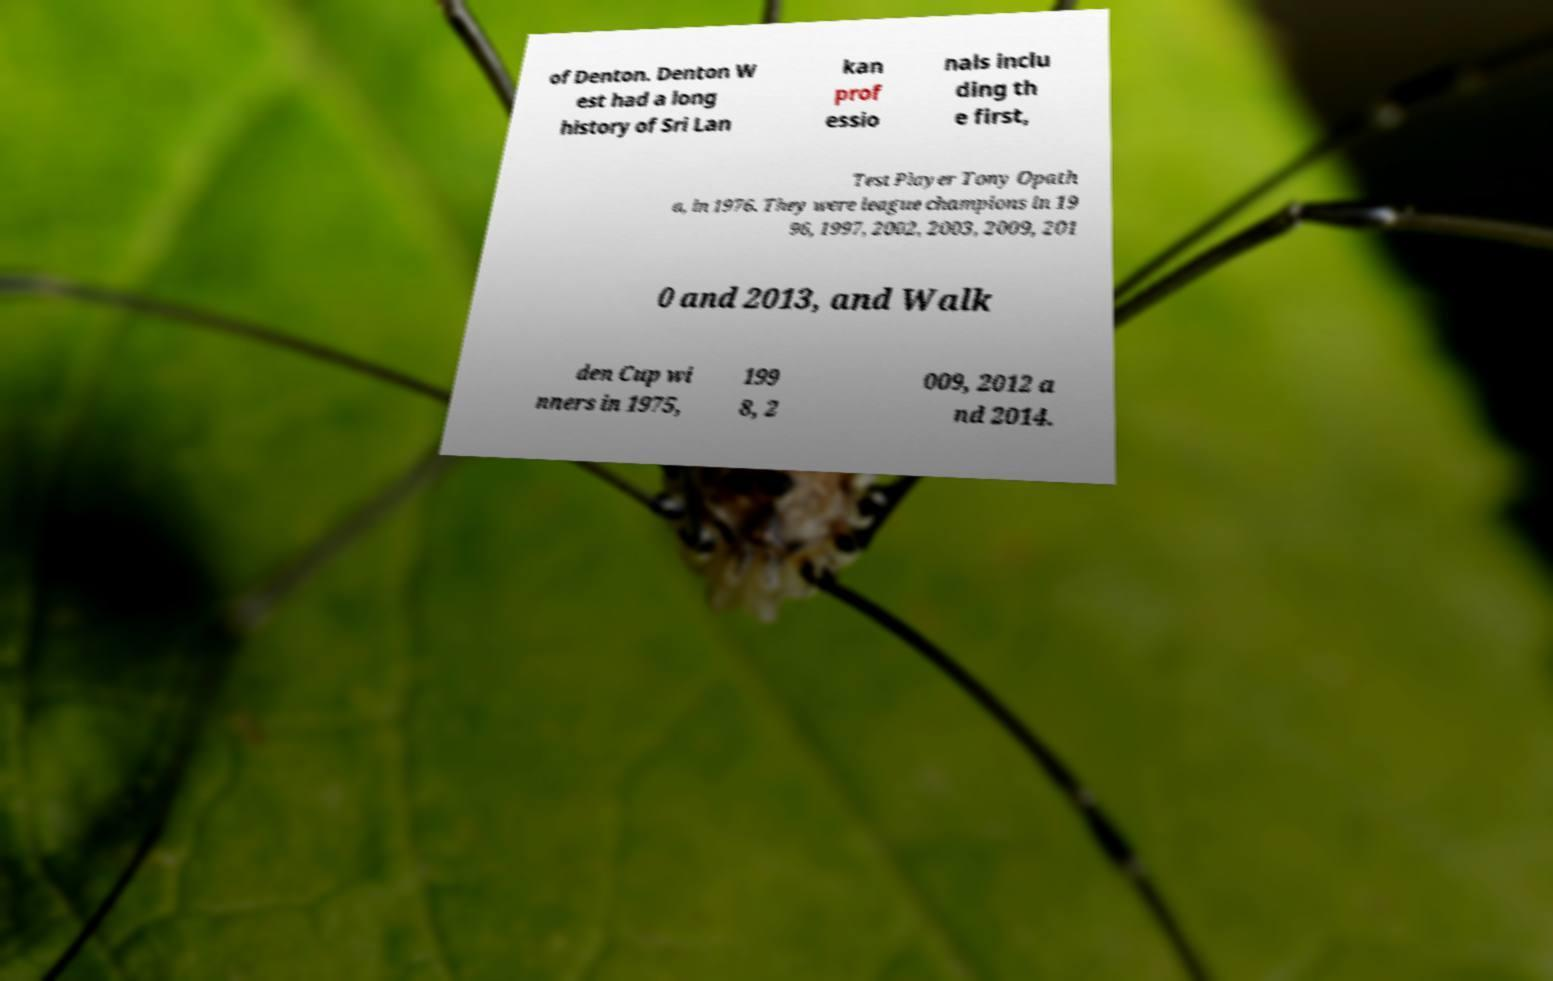Can you read and provide the text displayed in the image?This photo seems to have some interesting text. Can you extract and type it out for me? of Denton. Denton W est had a long history of Sri Lan kan prof essio nals inclu ding th e first, Test Player Tony Opath a, in 1976. They were league champions in 19 96, 1997, 2002, 2003, 2009, 201 0 and 2013, and Walk den Cup wi nners in 1975, 199 8, 2 009, 2012 a nd 2014. 